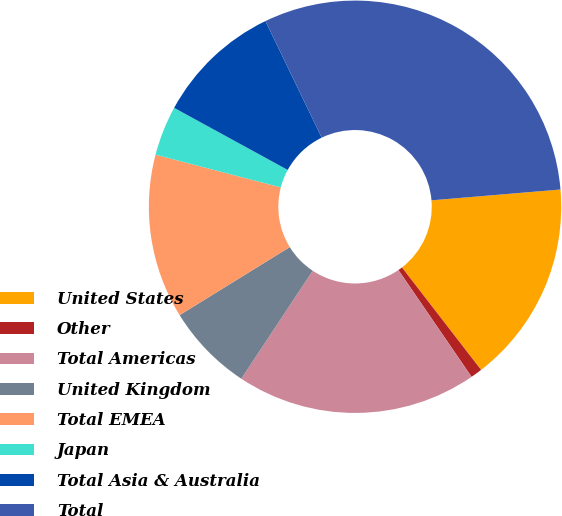Convert chart. <chart><loc_0><loc_0><loc_500><loc_500><pie_chart><fcel>United States<fcel>Other<fcel>Total Americas<fcel>United Kingdom<fcel>Total EMEA<fcel>Japan<fcel>Total Asia & Australia<fcel>Total<nl><fcel>15.86%<fcel>0.91%<fcel>18.86%<fcel>6.89%<fcel>12.87%<fcel>3.9%<fcel>9.88%<fcel>30.82%<nl></chart> 